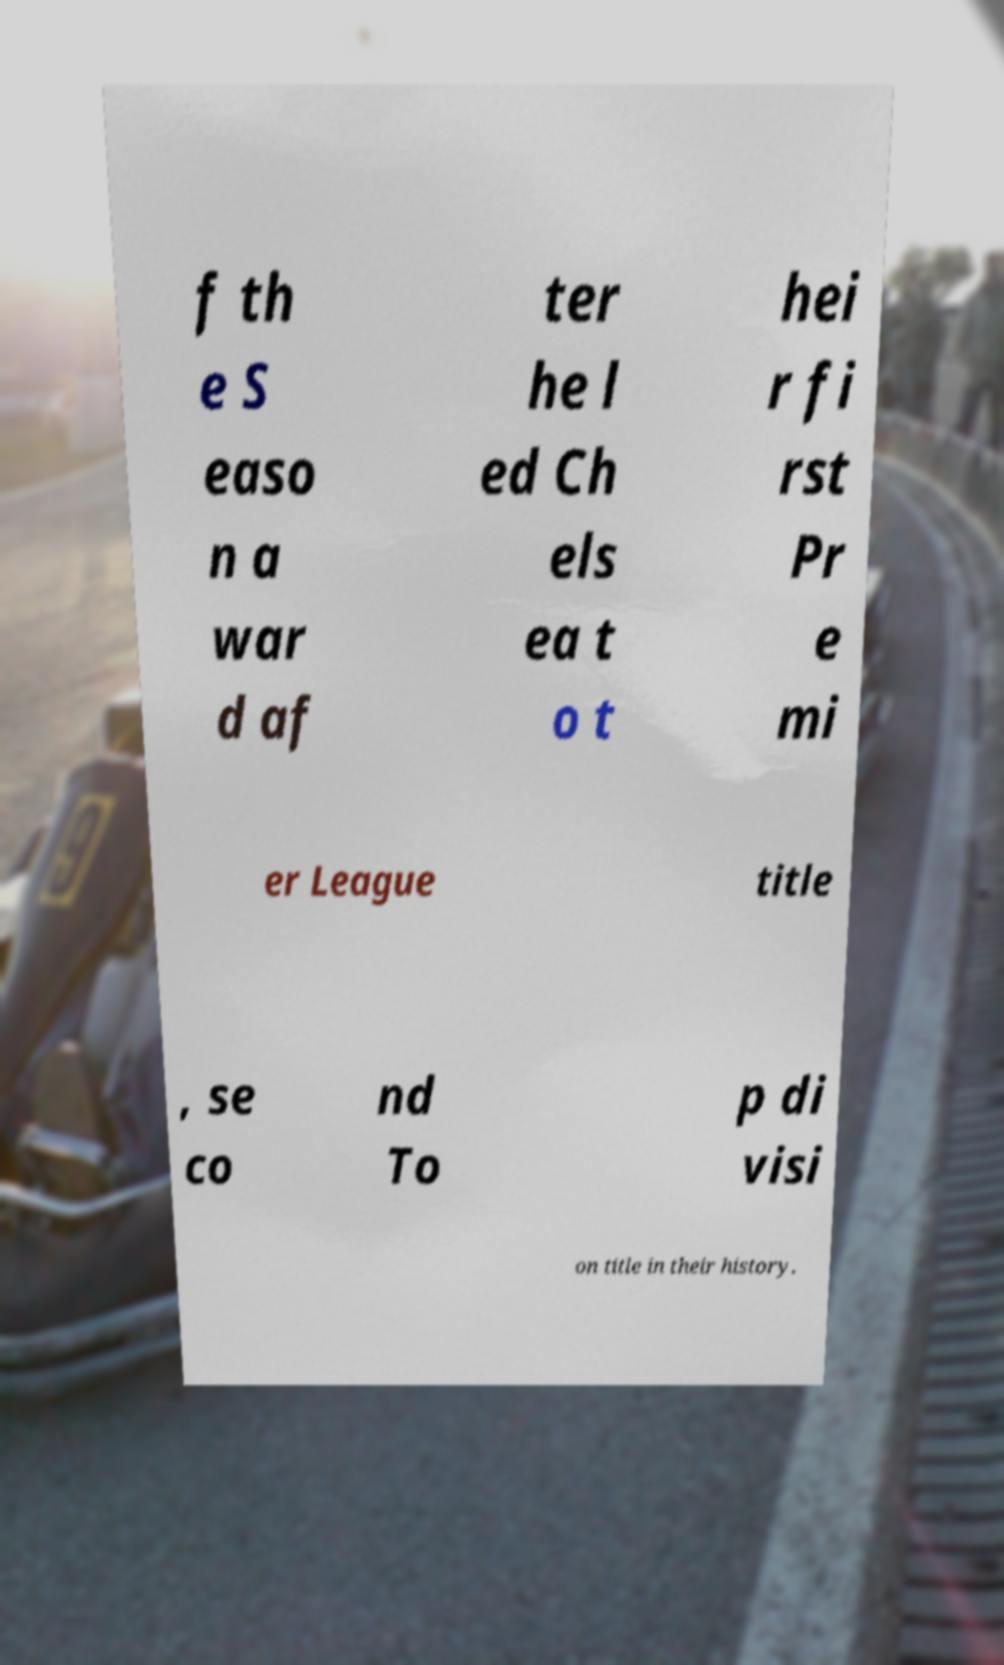What messages or text are displayed in this image? I need them in a readable, typed format. f th e S easo n a war d af ter he l ed Ch els ea t o t hei r fi rst Pr e mi er League title , se co nd To p di visi on title in their history. 